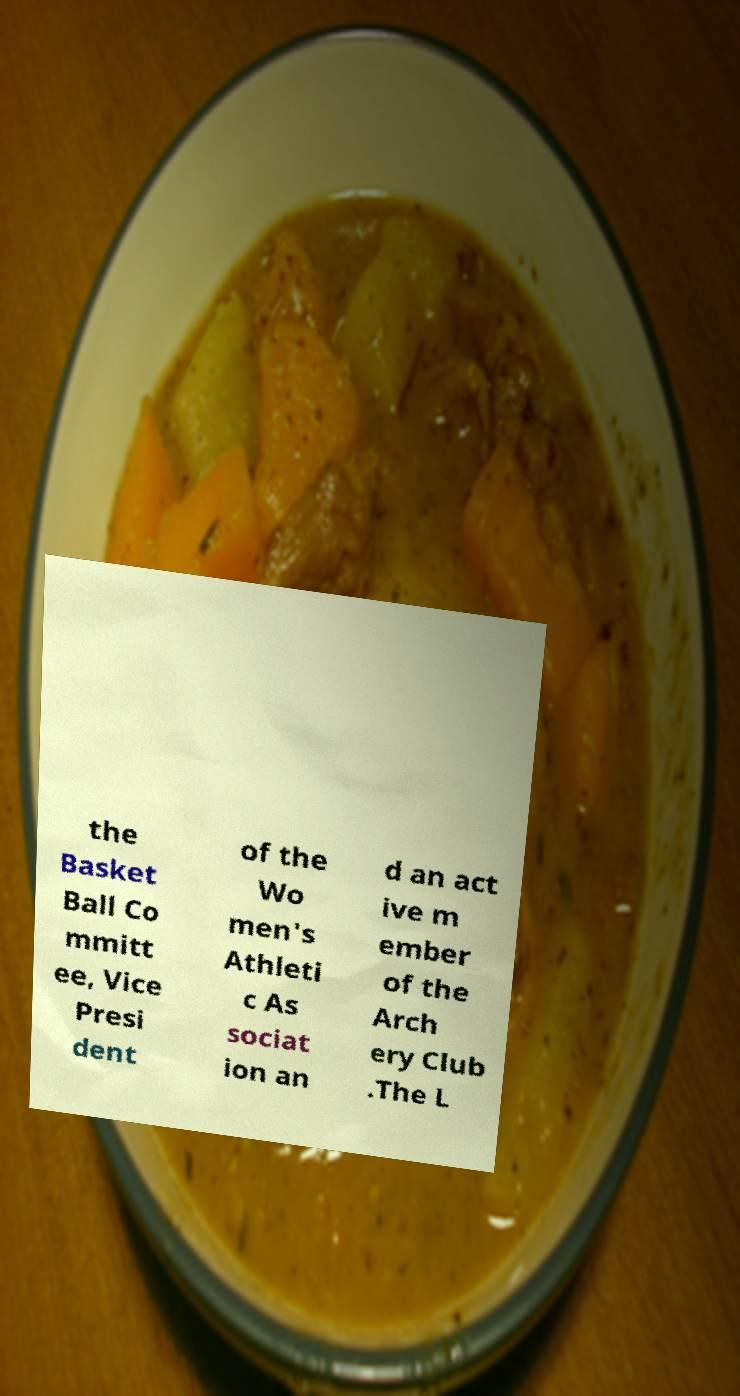Please identify and transcribe the text found in this image. the Basket Ball Co mmitt ee, Vice Presi dent of the Wo men's Athleti c As sociat ion an d an act ive m ember of the Arch ery Club .The L 